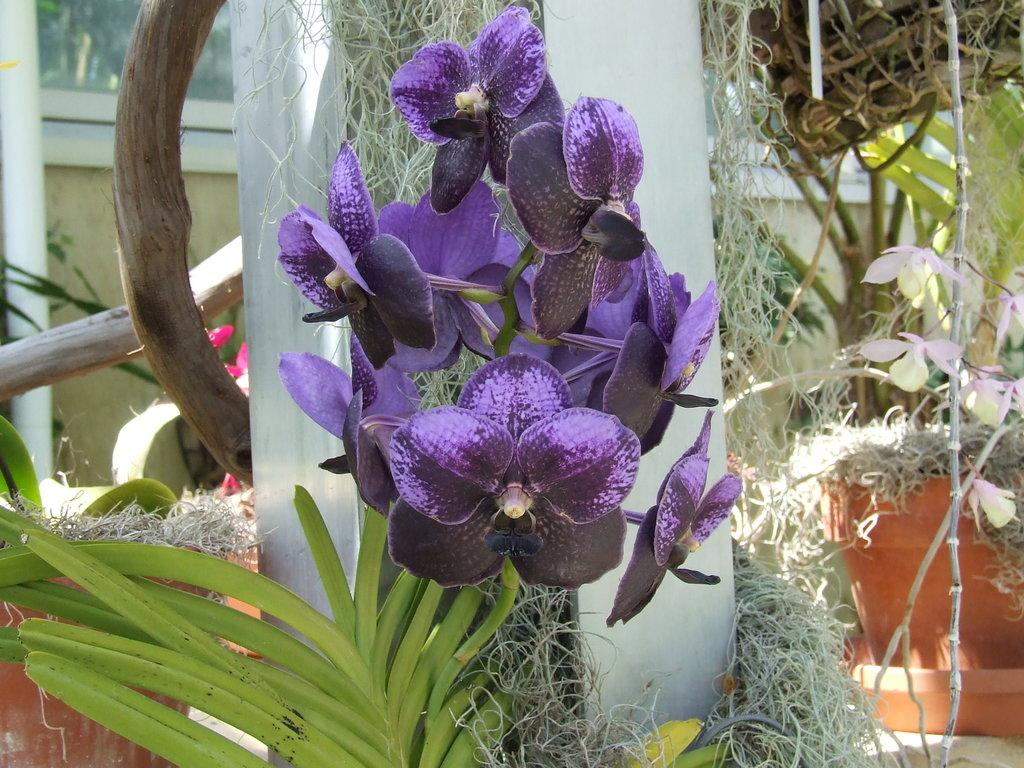What is the main subject in the center of the image? There are flowers in the center of the image. What other types of plants can be seen in the image? There are plants in the image. What architectural feature is present in the image? There is a pillar in the image. What can be seen in the background of the image? There is a glass window in the background of the image. What natural element is visible in the image? There is a tree branch visible in the image. What time of day is indicated on the calendar in the image? There is no calendar present in the image, so we cannot determine the time of day. 